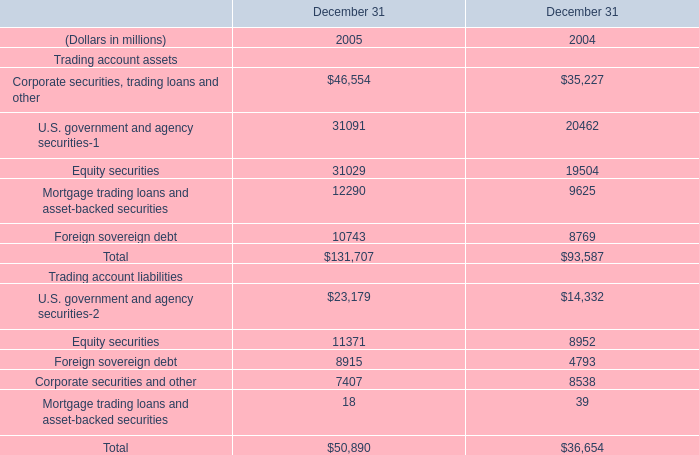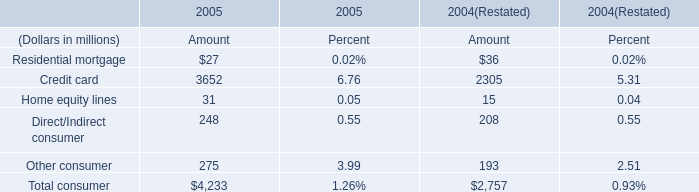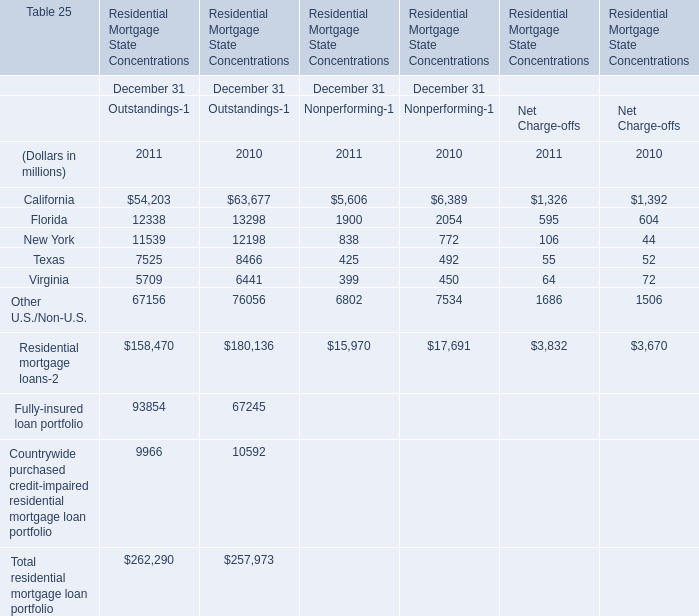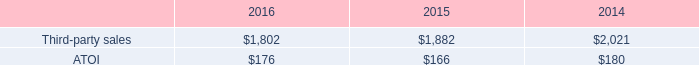What is the sum of Corporate securities, trading loans and other of December 31 2004, California of Residential Mortgage State Concentrations December 31 Nonperforming 2011, and California of Residential Mortgage State Concentrations December 31 Outstandings 2010 ? 
Computations: ((35227.0 + 5606.0) + 63677.0)
Answer: 104510.0. 